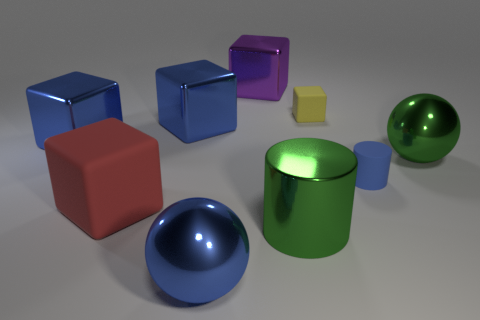Is the color of the tiny matte cylinder the same as the small matte cube?
Offer a very short reply. No. How many big green metallic cylinders are there?
Offer a very short reply. 1. How many balls are purple metal objects or blue matte things?
Provide a short and direct response. 0. How many big green metal objects are in front of the rubber block in front of the yellow thing?
Make the answer very short. 1. Does the purple cube have the same material as the blue sphere?
Keep it short and to the point. Yes. The metal thing that is the same color as the big metal cylinder is what size?
Provide a short and direct response. Large. Are there any purple objects that have the same material as the red object?
Ensure brevity in your answer.  No. What is the color of the small rubber thing left of the tiny blue rubber thing that is in front of the cube that is right of the purple object?
Provide a short and direct response. Yellow. What number of purple objects are tiny matte blocks or small objects?
Offer a terse response. 0. How many large red rubber objects are the same shape as the tiny yellow thing?
Offer a terse response. 1. 